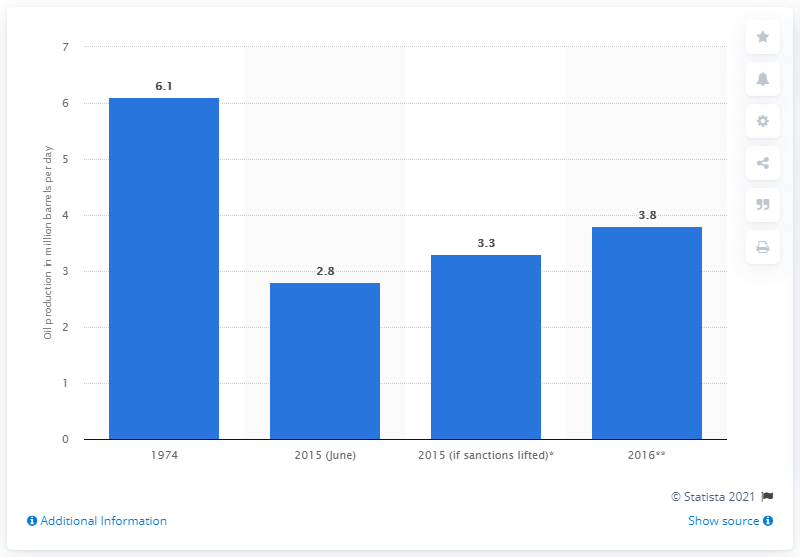Give some essential details in this illustration. As of June 2015, Iran produced an average of 2.8 barrels of oil per day. 